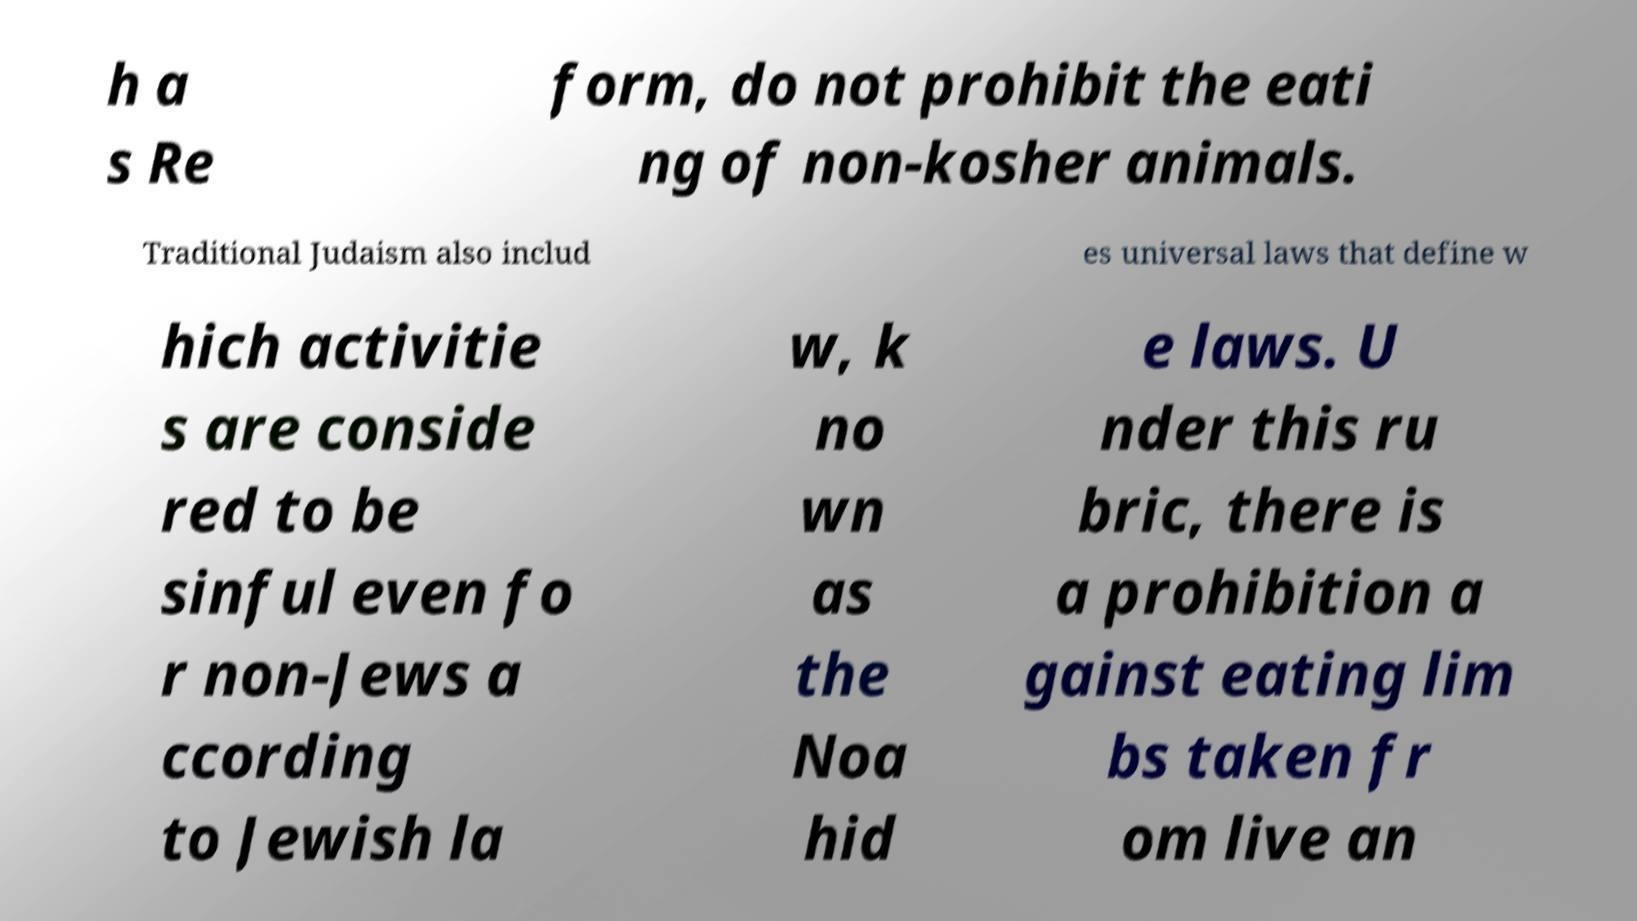For documentation purposes, I need the text within this image transcribed. Could you provide that? h a s Re form, do not prohibit the eati ng of non-kosher animals. Traditional Judaism also includ es universal laws that define w hich activitie s are conside red to be sinful even fo r non-Jews a ccording to Jewish la w, k no wn as the Noa hid e laws. U nder this ru bric, there is a prohibition a gainst eating lim bs taken fr om live an 